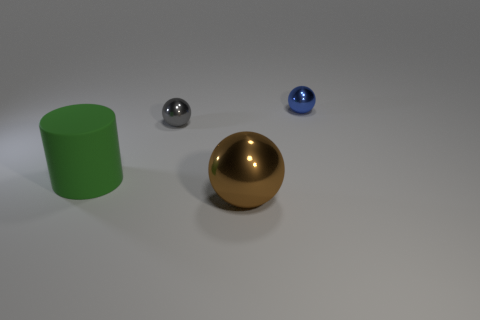What is the material of the big thing that is in front of the green matte cylinder? metal 